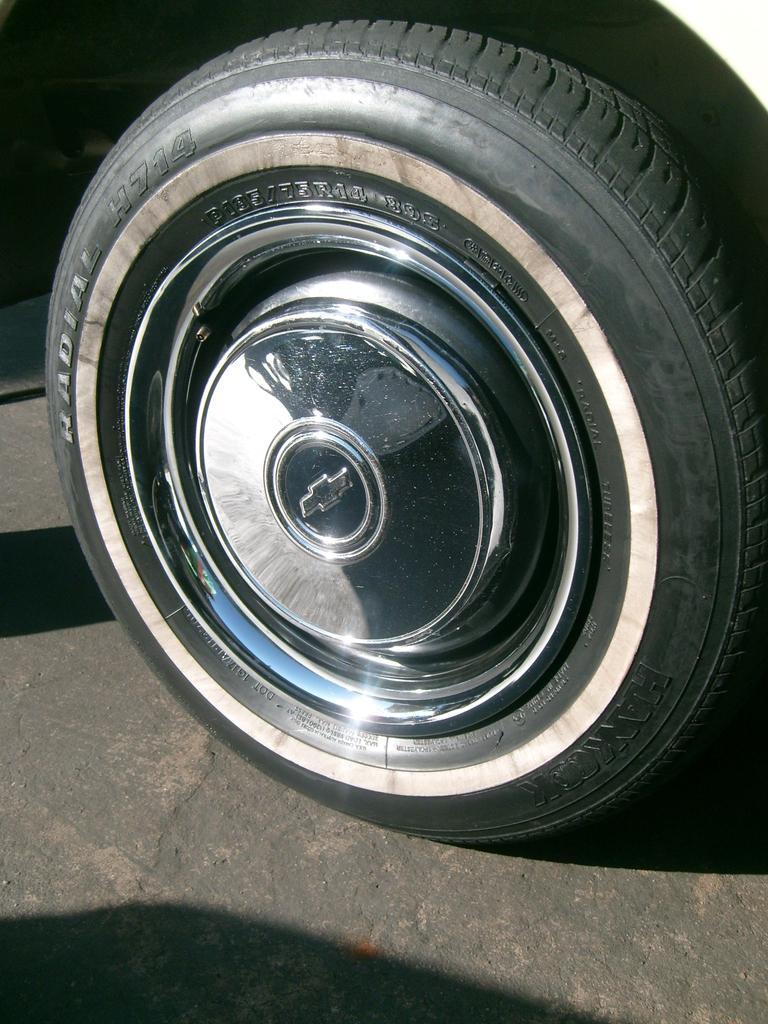Could you give a brief overview of what you see in this image? In this image we can see the Tyre of a vehicle. There is a metal in the middle of the Tyre. The Tyre is on the floor. 